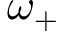<formula> <loc_0><loc_0><loc_500><loc_500>\omega _ { + }</formula> 